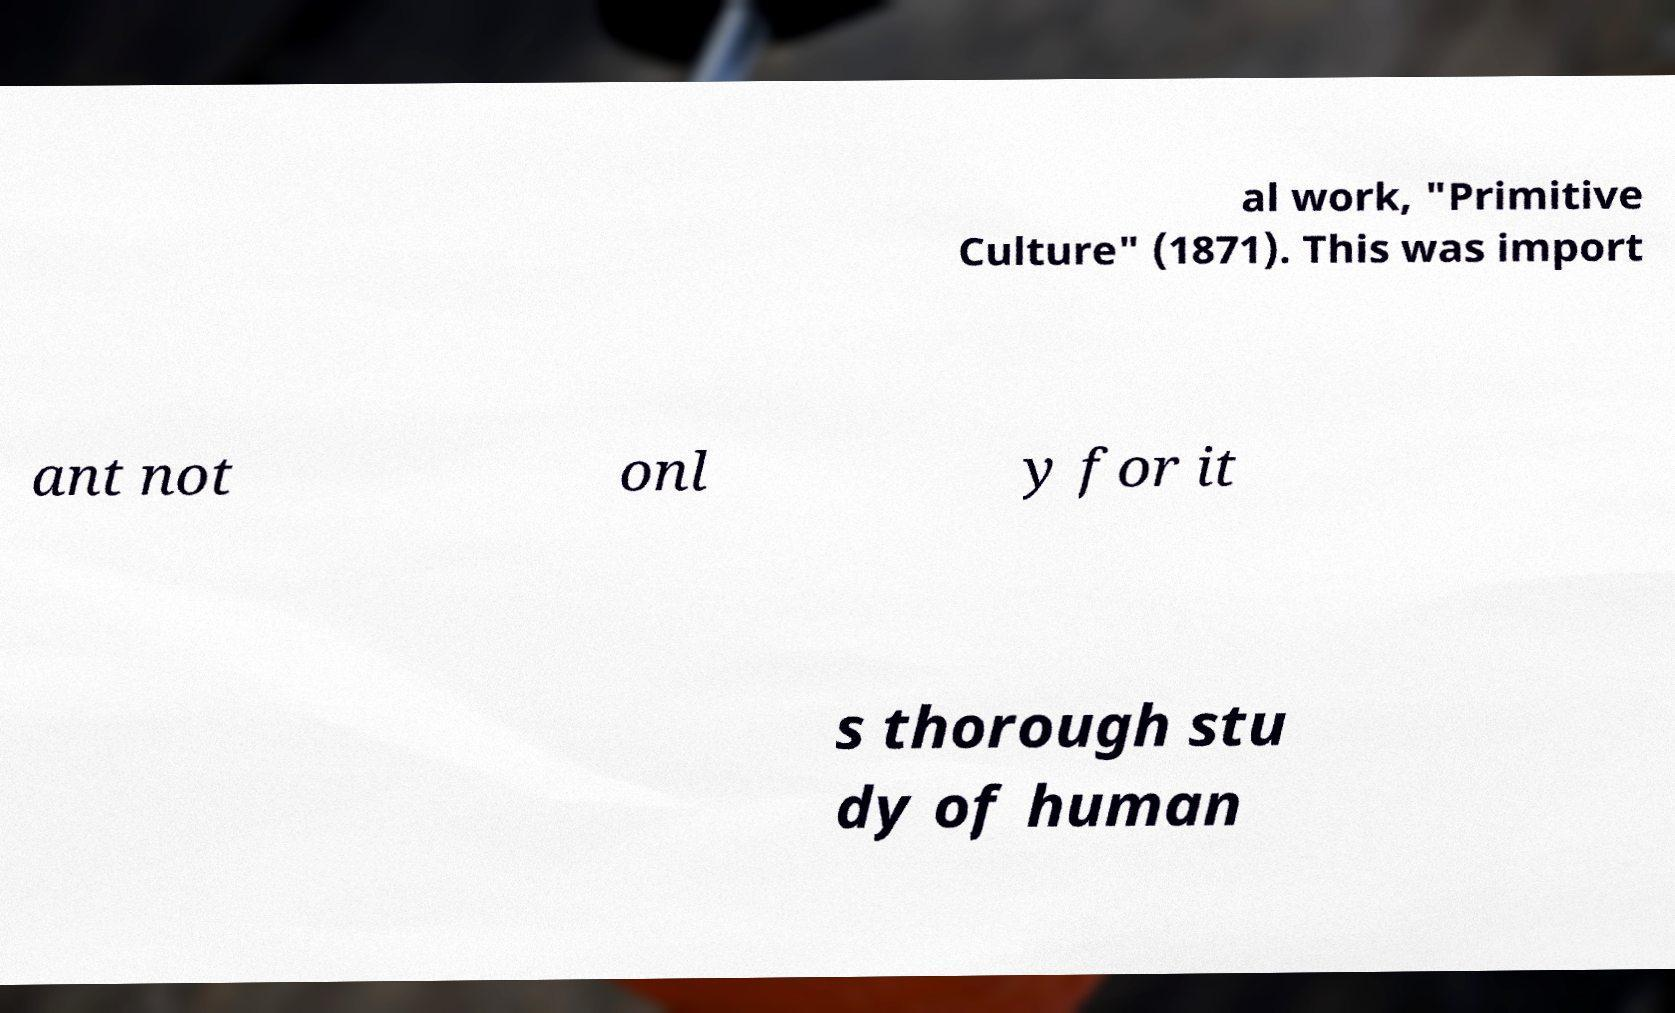I need the written content from this picture converted into text. Can you do that? al work, "Primitive Culture" (1871). This was import ant not onl y for it s thorough stu dy of human 